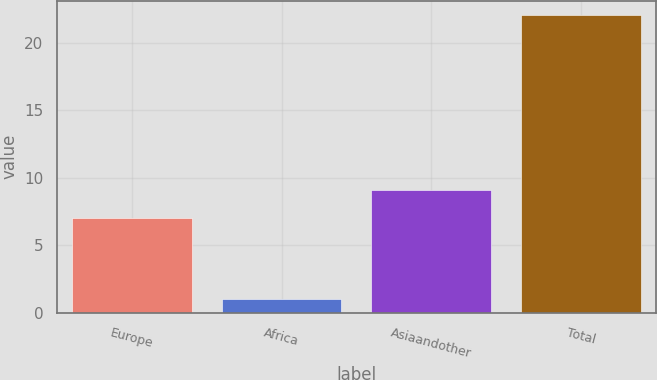Convert chart to OTSL. <chart><loc_0><loc_0><loc_500><loc_500><bar_chart><fcel>Europe<fcel>Africa<fcel>Asiaandother<fcel>Total<nl><fcel>7<fcel>1<fcel>9.1<fcel>22<nl></chart> 